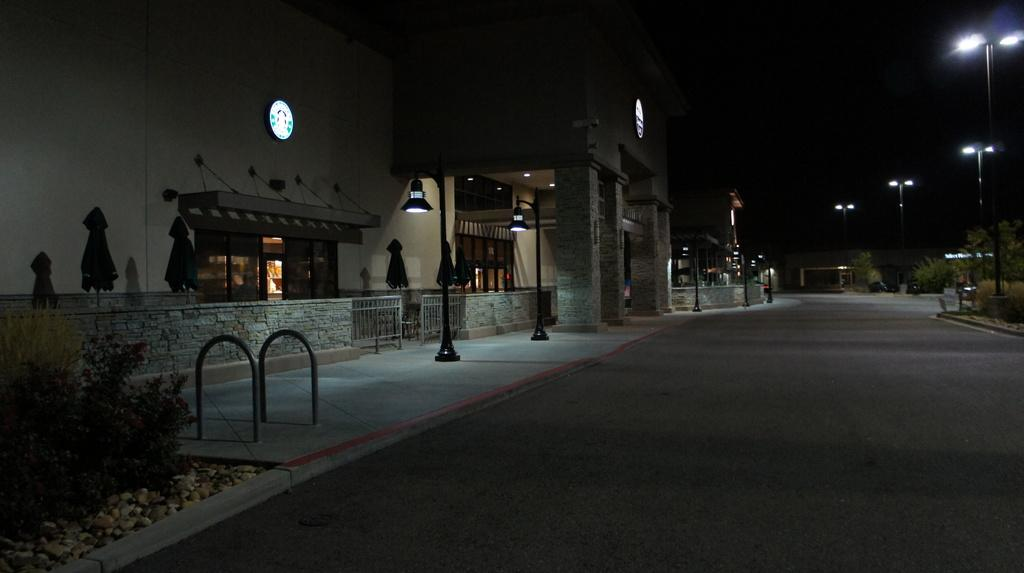What is the main focus of the image? The main focus of the image is the buildings in the center. What other elements can be seen in the image? There are plants, poles, lights, pillars, fences, stones, clothes, and round shape objects with lights in the image. Can you describe the round shape objects with lights? The round shape objects with lights are likely streetlights or lamps. How many vehicles are visible in the image? There is only one vehicle visible in the image. What type of objects are the poles and pillars supporting? The poles and pillars are likely supporting lights or other structures. Where are the worms and crates located in the image? There are no worms or crates present in the image. What type of berries can be seen growing on the plants in the image? There are no berries visible on the plants in the image. 